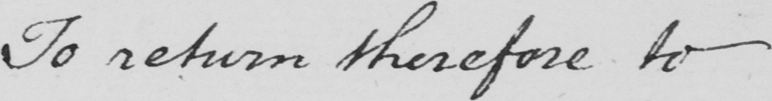Please transcribe the handwritten text in this image. To return therefore to 